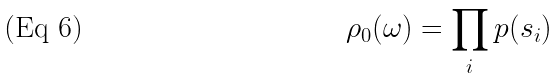<formula> <loc_0><loc_0><loc_500><loc_500>\rho _ { 0 } ( \omega ) = \prod _ { i } p ( s _ { i } )</formula> 